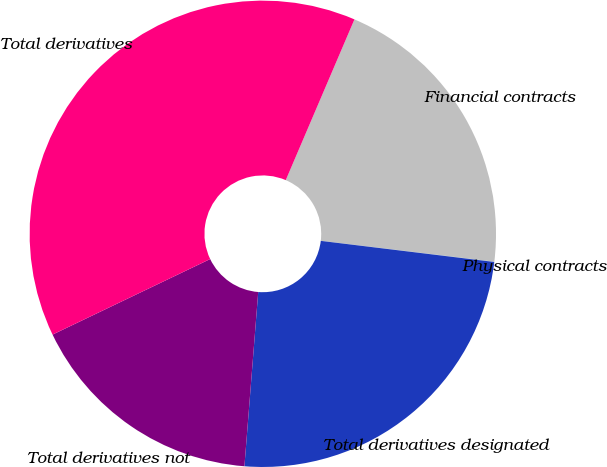Convert chart. <chart><loc_0><loc_0><loc_500><loc_500><pie_chart><fcel>Financial contracts<fcel>Physical contracts<fcel>Total derivatives designated<fcel>Total derivatives not<fcel>Total derivatives<nl><fcel>20.48%<fcel>0.02%<fcel>24.33%<fcel>16.63%<fcel>38.54%<nl></chart> 